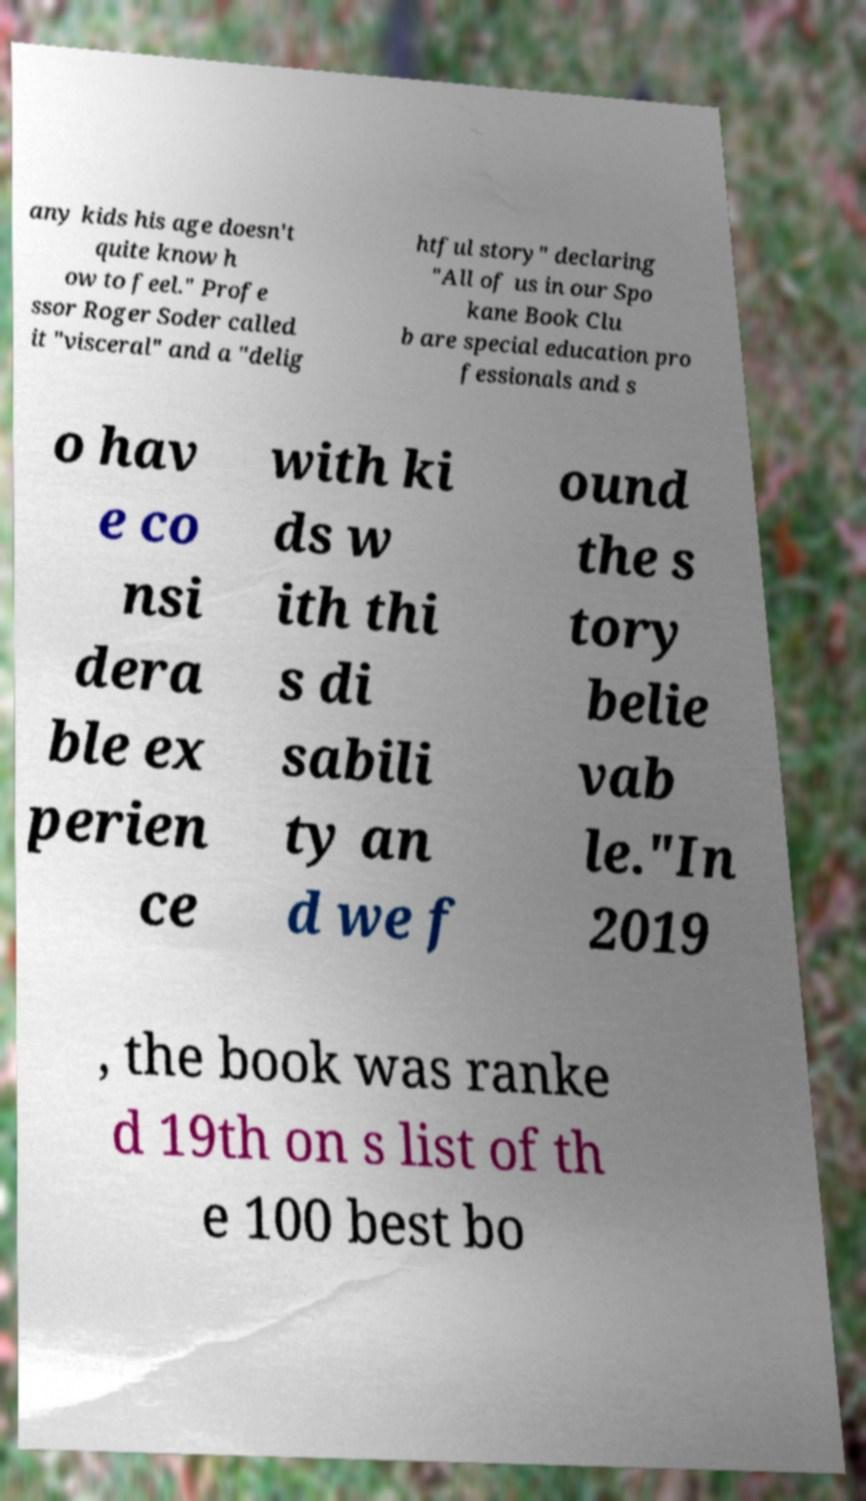I need the written content from this picture converted into text. Can you do that? any kids his age doesn't quite know h ow to feel." Profe ssor Roger Soder called it "visceral" and a "delig htful story" declaring "All of us in our Spo kane Book Clu b are special education pro fessionals and s o hav e co nsi dera ble ex perien ce with ki ds w ith thi s di sabili ty an d we f ound the s tory belie vab le."In 2019 , the book was ranke d 19th on s list of th e 100 best bo 